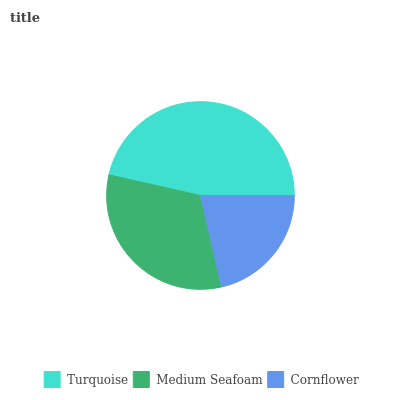Is Cornflower the minimum?
Answer yes or no. Yes. Is Turquoise the maximum?
Answer yes or no. Yes. Is Medium Seafoam the minimum?
Answer yes or no. No. Is Medium Seafoam the maximum?
Answer yes or no. No. Is Turquoise greater than Medium Seafoam?
Answer yes or no. Yes. Is Medium Seafoam less than Turquoise?
Answer yes or no. Yes. Is Medium Seafoam greater than Turquoise?
Answer yes or no. No. Is Turquoise less than Medium Seafoam?
Answer yes or no. No. Is Medium Seafoam the high median?
Answer yes or no. Yes. Is Medium Seafoam the low median?
Answer yes or no. Yes. Is Cornflower the high median?
Answer yes or no. No. Is Cornflower the low median?
Answer yes or no. No. 